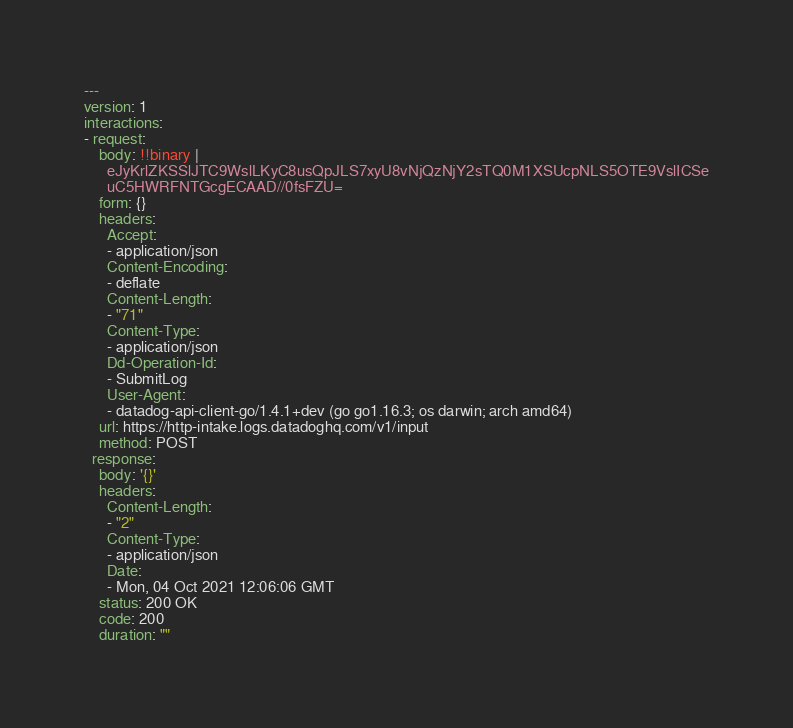<code> <loc_0><loc_0><loc_500><loc_500><_YAML_>---
version: 1
interactions:
- request:
    body: !!binary |
      eJyKrlZKSSlJTC9WslLKyC8usQpJLS7xyU8vNjQzNjY2sTQ0M1XSUcpNLS5OTE9VslICSe
      uC5HWRFNTGcgECAAD//0fsFZU=
    form: {}
    headers:
      Accept:
      - application/json
      Content-Encoding:
      - deflate
      Content-Length:
      - "71"
      Content-Type:
      - application/json
      Dd-Operation-Id:
      - SubmitLog
      User-Agent:
      - datadog-api-client-go/1.4.1+dev (go go1.16.3; os darwin; arch amd64)
    url: https://http-intake.logs.datadoghq.com/v1/input
    method: POST
  response:
    body: '{}'
    headers:
      Content-Length:
      - "2"
      Content-Type:
      - application/json
      Date:
      - Mon, 04 Oct 2021 12:06:06 GMT
    status: 200 OK
    code: 200
    duration: ""
</code> 